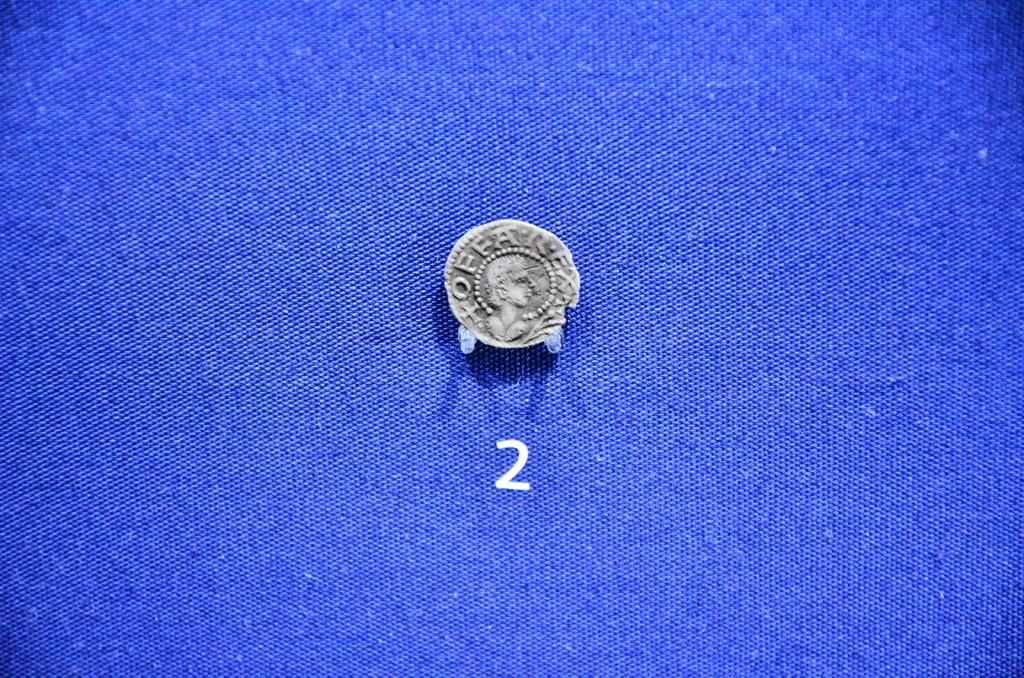Provide a one-sentence caption for the provided image. The coin is number 2 on the blue table. 